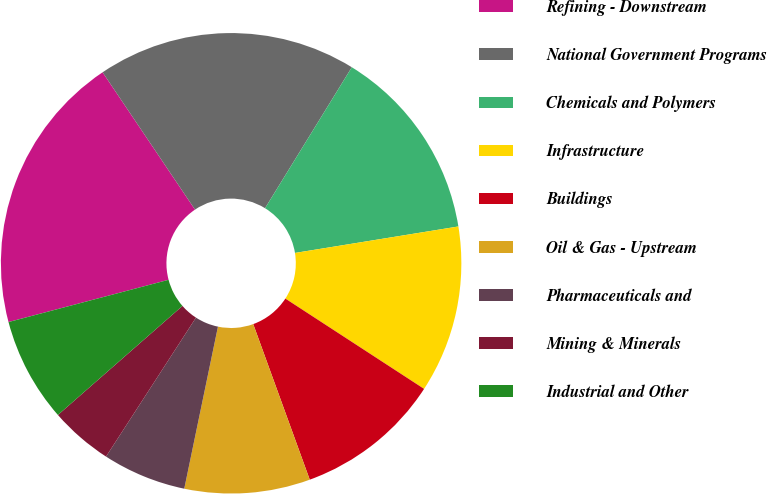Convert chart. <chart><loc_0><loc_0><loc_500><loc_500><pie_chart><fcel>Refining - Downstream<fcel>National Government Programs<fcel>Chemicals and Polymers<fcel>Infrastructure<fcel>Buildings<fcel>Oil & Gas - Upstream<fcel>Pharmaceuticals and<fcel>Mining & Minerals<fcel>Industrial and Other<nl><fcel>19.68%<fcel>18.21%<fcel>13.66%<fcel>11.74%<fcel>10.27%<fcel>8.81%<fcel>5.88%<fcel>4.41%<fcel>7.34%<nl></chart> 